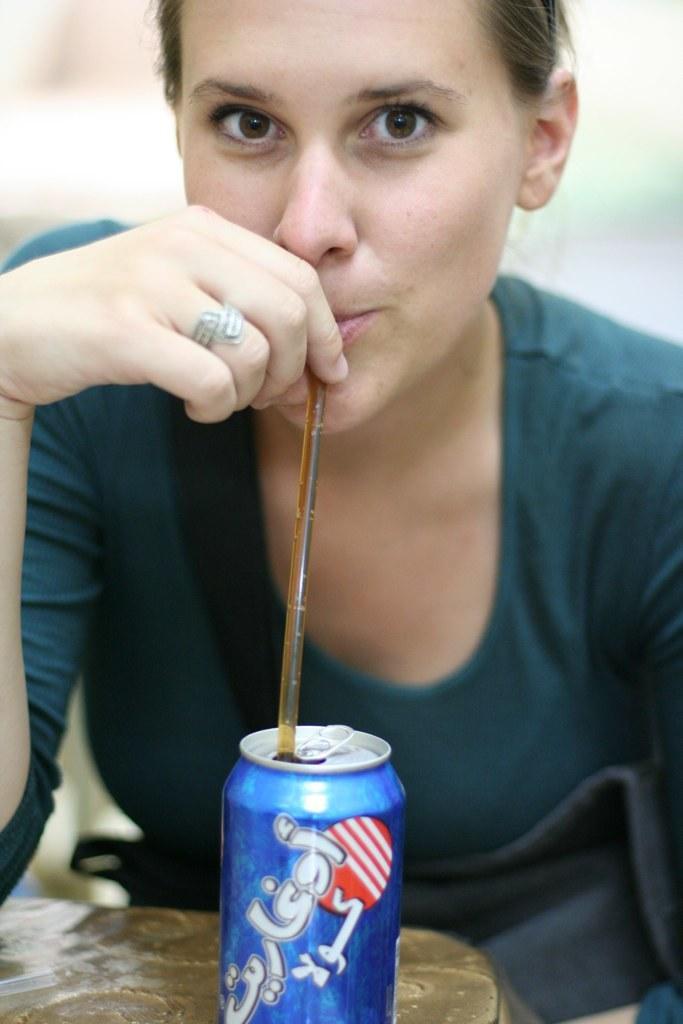Could you give a brief overview of what you see in this image? A woman is wearing a green t shirt and drinking a drink through straw. There is a blue can in front of her. 